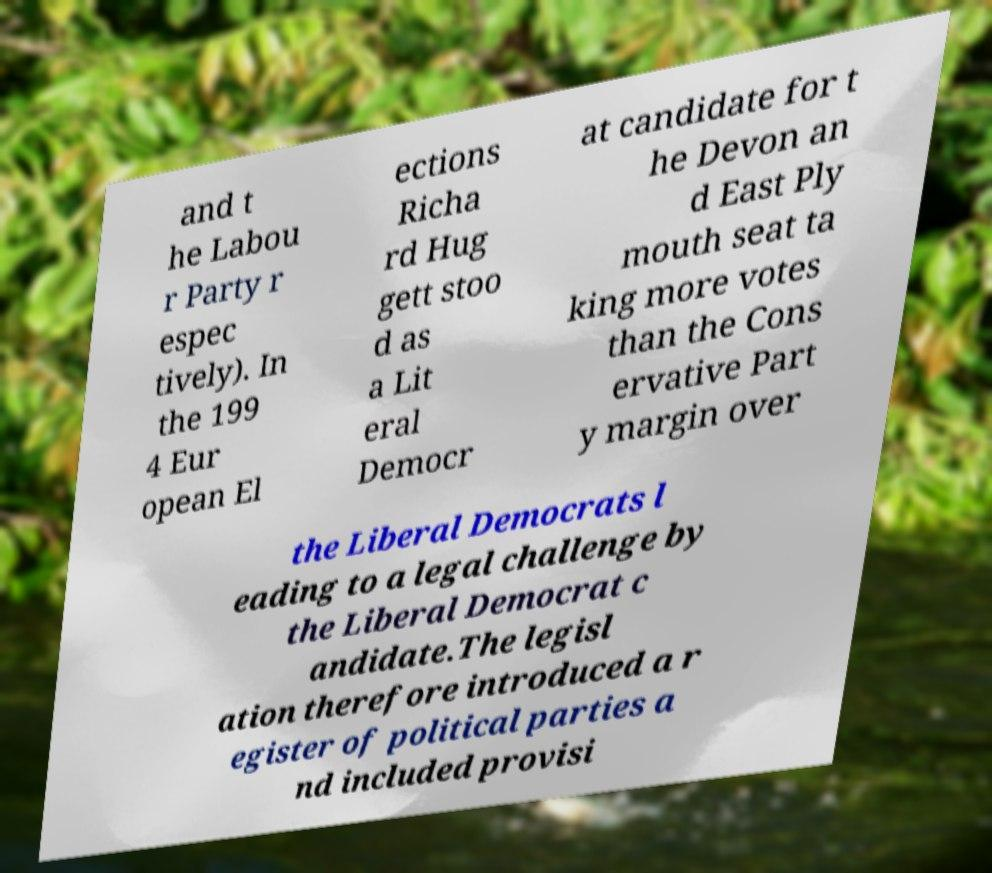Could you extract and type out the text from this image? and t he Labou r Party r espec tively). In the 199 4 Eur opean El ections Richa rd Hug gett stoo d as a Lit eral Democr at candidate for t he Devon an d East Ply mouth seat ta king more votes than the Cons ervative Part y margin over the Liberal Democrats l eading to a legal challenge by the Liberal Democrat c andidate.The legisl ation therefore introduced a r egister of political parties a nd included provisi 